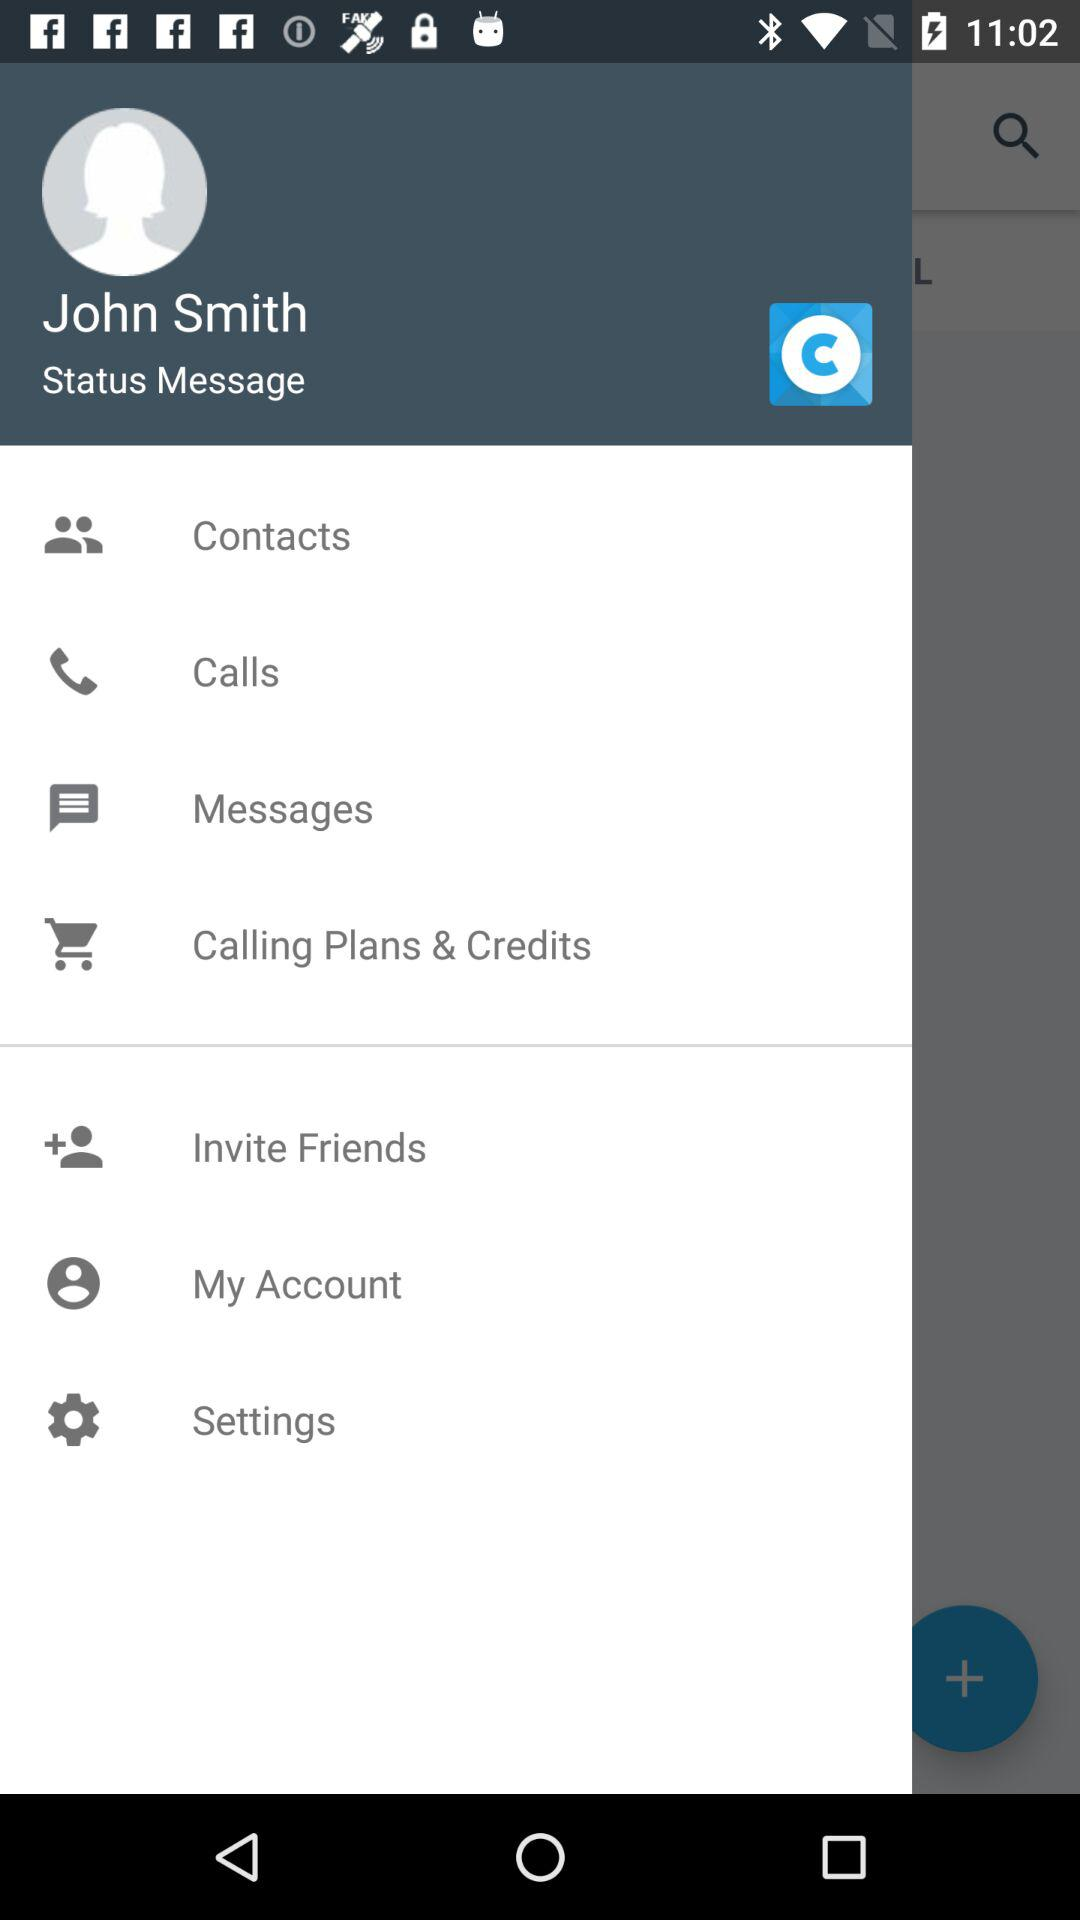When was the last message received?
When the provided information is insufficient, respond with <no answer>. <no answer> 